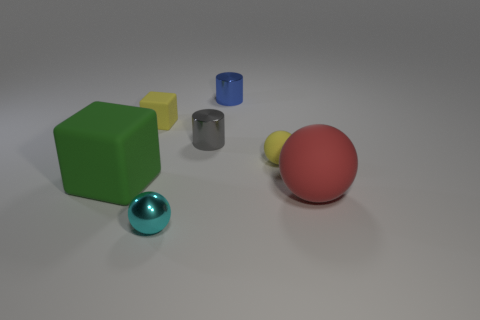Is the number of blue metallic things greater than the number of large things?
Provide a succinct answer. No. How many things are matte spheres that are left of the big ball or small red metal balls?
Your answer should be compact. 1. Do the red sphere and the cyan ball have the same material?
Offer a very short reply. No. The red rubber thing that is the same shape as the tiny cyan metal thing is what size?
Give a very brief answer. Large. There is a big thing that is behind the large red ball; does it have the same shape as the yellow object left of the cyan metal object?
Keep it short and to the point. Yes. There is a green matte thing; is it the same size as the yellow matte thing that is left of the small metallic sphere?
Give a very brief answer. No. How many other things are made of the same material as the gray object?
Make the answer very short. 2. The thing that is left of the tiny thing that is on the left side of the sphere in front of the large red thing is what color?
Your answer should be very brief. Green. The shiny thing that is in front of the yellow matte block and on the right side of the small cyan thing has what shape?
Your answer should be very brief. Cylinder. What is the color of the cylinder that is in front of the small metallic object to the right of the gray thing?
Your answer should be very brief. Gray. 